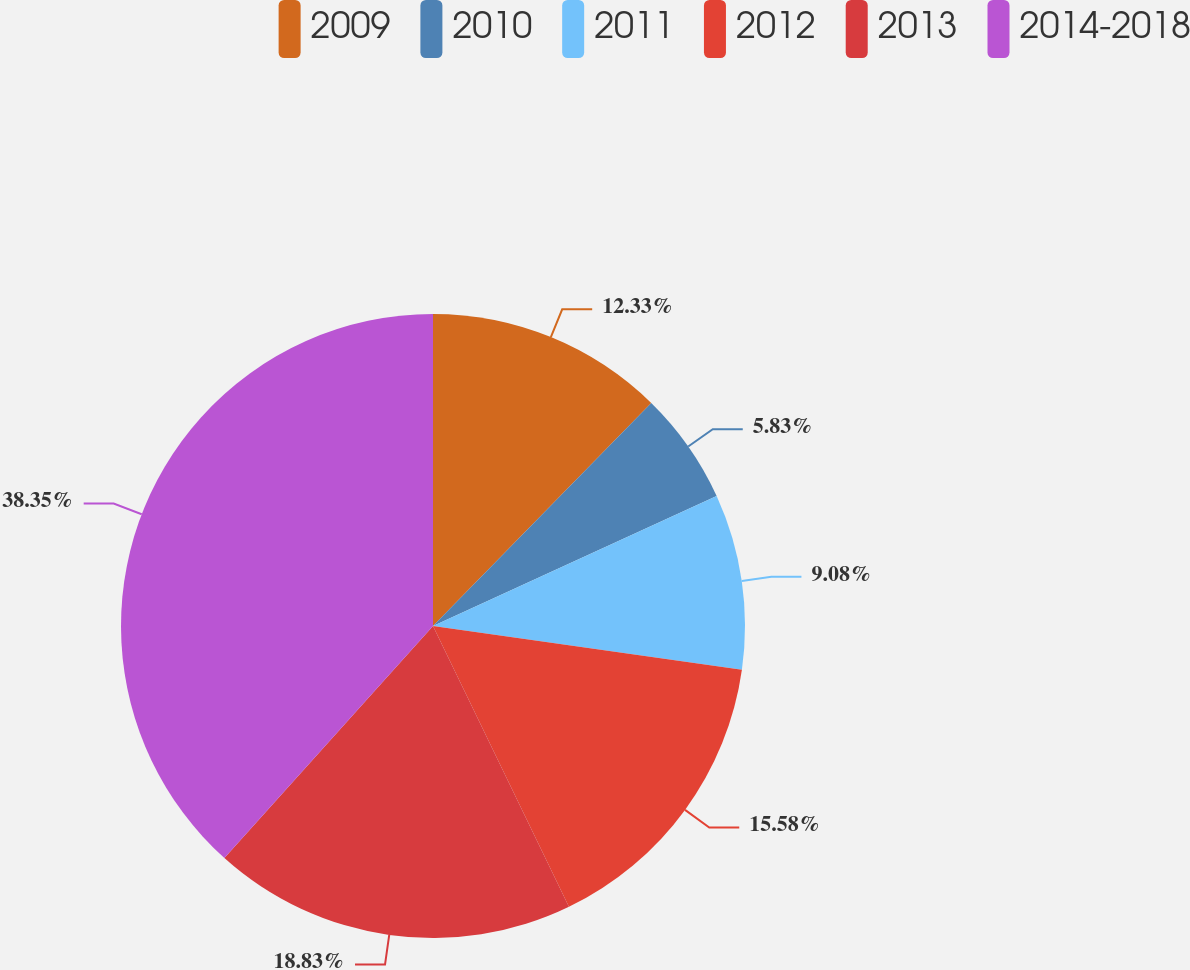<chart> <loc_0><loc_0><loc_500><loc_500><pie_chart><fcel>2009<fcel>2010<fcel>2011<fcel>2012<fcel>2013<fcel>2014-2018<nl><fcel>12.33%<fcel>5.83%<fcel>9.08%<fcel>15.58%<fcel>18.83%<fcel>38.34%<nl></chart> 